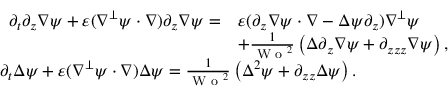Convert formula to latex. <formula><loc_0><loc_0><loc_500><loc_500>\begin{array} { r l } & { \begin{array} { r l } { \partial _ { t } \partial _ { z } \nabla \psi + \varepsilon ( \nabla ^ { \perp } \psi \cdot \nabla ) \partial _ { z } \nabla \psi = } & { \varepsilon ( \partial _ { z } \nabla \psi \cdot \nabla - \Delta \psi \partial _ { z } ) \nabla ^ { \perp } \psi } \\ & { + \frac { 1 } { W o ^ { 2 } } \left ( \Delta \partial _ { z } \nabla \psi + \partial _ { z z z } \nabla \psi \right ) , } \end{array} } \\ & { \partial _ { t } \Delta \psi + \varepsilon ( \nabla ^ { \perp } \psi \cdot \nabla ) \Delta \psi = \frac { 1 } { W o ^ { 2 } } \left ( \Delta ^ { 2 } \psi + \partial _ { z z } \Delta \psi \right ) . } \end{array}</formula> 